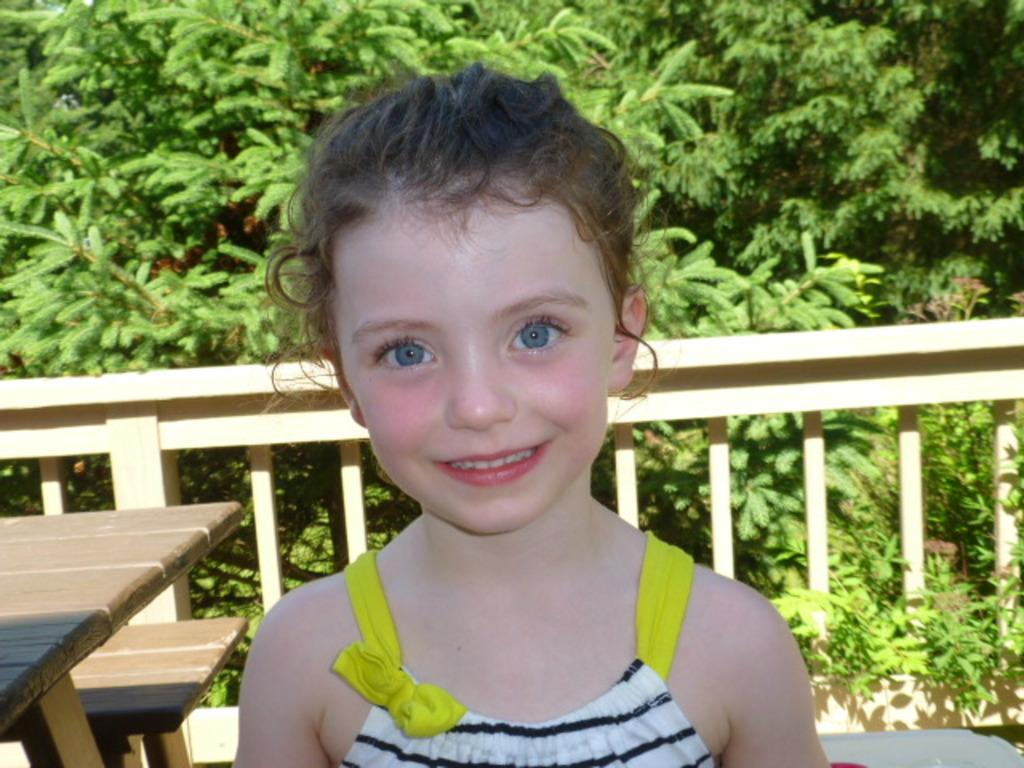What is the main subject of the image? The main subject of the image is a kid. What is the kid wearing in the image? The kid is wearing a white dress in the image. What is the kid doing in the image? The kid is looking at the camera in the image. What can be seen in the background of the image? There are trees and fencing in the background of the image. Can you see any airplanes taking off at the nearby airport in the image? There is no airport or airplanes visible in the image. Is the kid playing basketball in the image? There is no basketball or indication of the kid playing basketball in the image. 